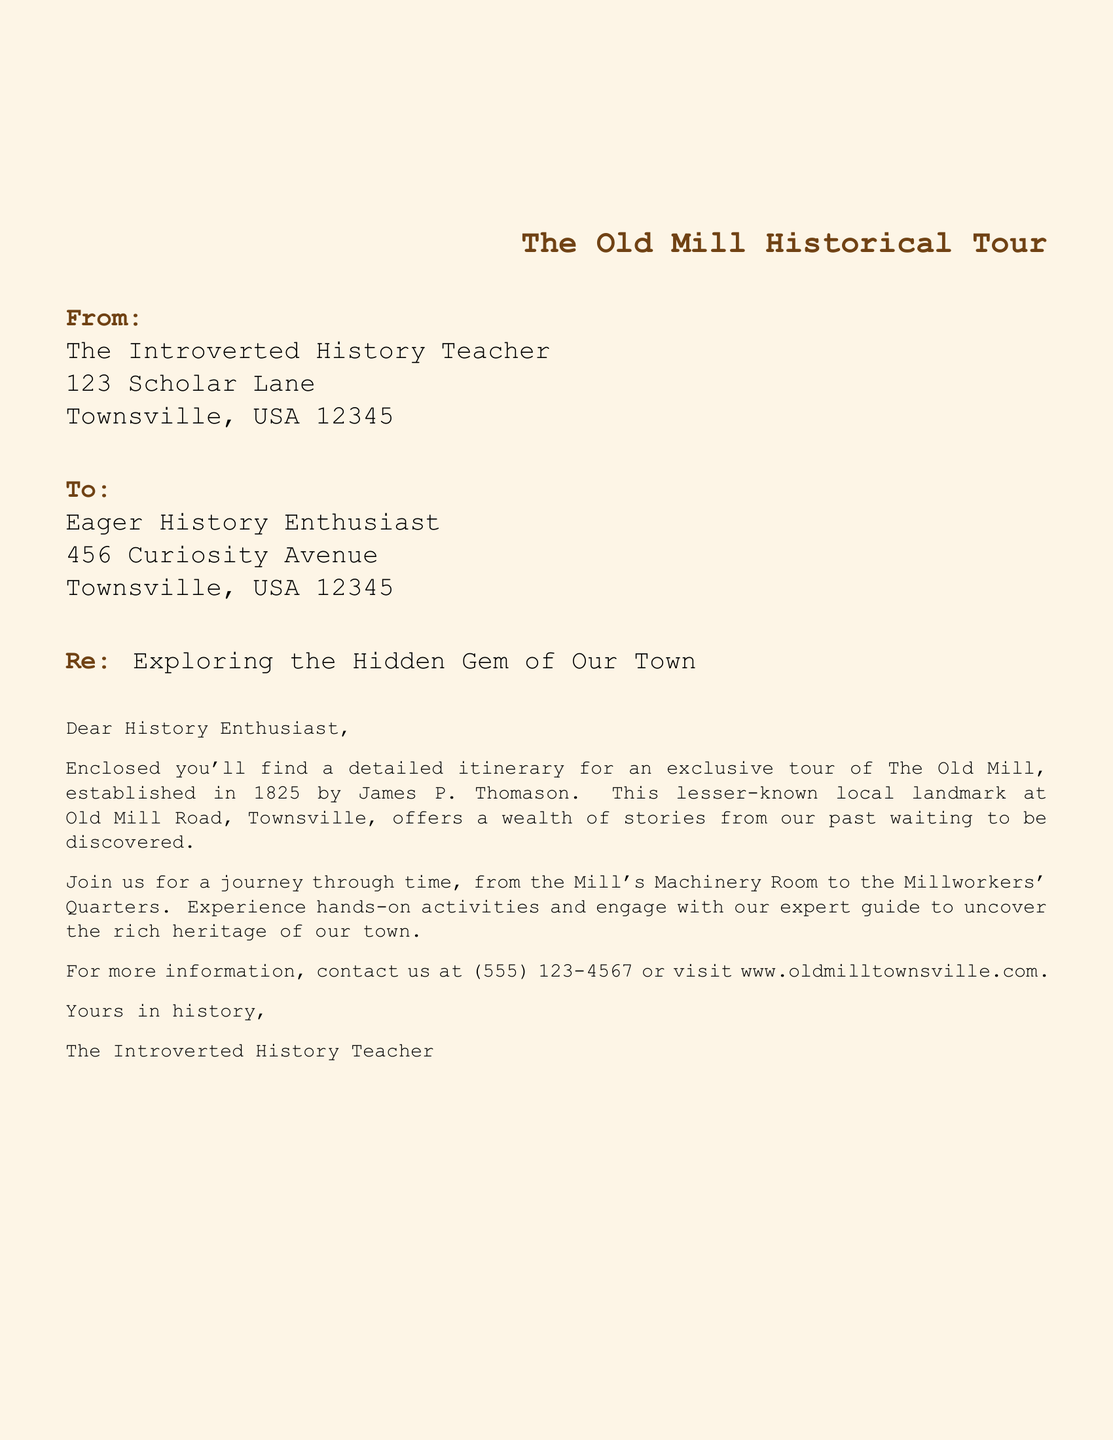What is the name of the historical landmark? The document specifically states that the historical landmark is called The Old Mill.
Answer: The Old Mill Who established The Old Mill? According to the document, The Old Mill was established by James P. Thomason.
Answer: James P. Thomason In what year was The Old Mill established? The document indicates that The Old Mill was established in the year 1825.
Answer: 1825 What is the contact number provided for more information? The document includes a contact number for inquiries, which is (555) 123-4567.
Answer: (555) 123-4567 What activities will participants engage in during the tour? The document mentions that participants will experience hands-on activities and engage with an expert guide.
Answer: hands-on activities Where is The Old Mill located? The document provides the location as Old Mill Road, Townsville.
Answer: Old Mill Road, Townsville Who is the sender of the letter? The document states that the sender of the letter is The Introverted History Teacher.
Answer: The Introverted History Teacher What is the purpose of the letter? The document's purpose is to provide a detailed itinerary for a historical tour of The Old Mill.
Answer: detailed itinerary for a historical tour What tone does the letter convey? The letter conveys a formal and informative tone as it addresses a history enthusiast and provides details about an event.
Answer: formal and informative 